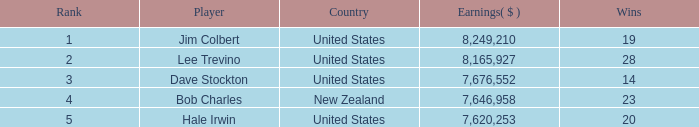How many average wins for players ranked below 2 with earnings greater than $7,676,552? None. Can you give me this table as a dict? {'header': ['Rank', 'Player', 'Country', 'Earnings( $ )', 'Wins'], 'rows': [['1', 'Jim Colbert', 'United States', '8,249,210', '19'], ['2', 'Lee Trevino', 'United States', '8,165,927', '28'], ['3', 'Dave Stockton', 'United States', '7,676,552', '14'], ['4', 'Bob Charles', 'New Zealand', '7,646,958', '23'], ['5', 'Hale Irwin', 'United States', '7,620,253', '20']]} 